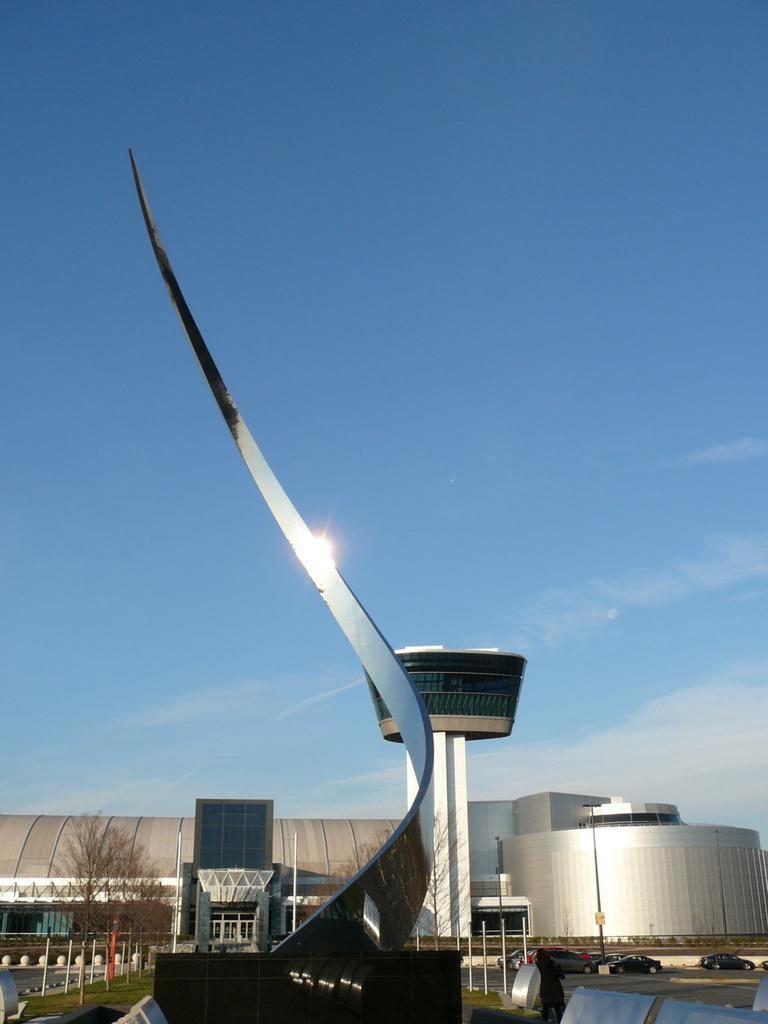Describe this image in one or two sentences. There are buildings and plants. 